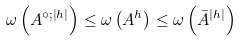Convert formula to latex. <formula><loc_0><loc_0><loc_500><loc_500>\omega \left ( A ^ { \circ ; \left | h \right | } \right ) \leq \omega \left ( A ^ { h } \right ) \leq \omega \left ( \bar { A } ^ { \left | h \right | } \right )</formula> 